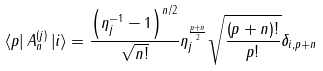Convert formula to latex. <formula><loc_0><loc_0><loc_500><loc_500>\left \langle p \right | A _ { n } ^ { ( j ) } \left | i \right \rangle = \frac { \left ( { \eta _ { j } ^ { - 1 } - 1 } \right ) ^ { n / 2 } } { \sqrt { n ! } } \eta _ { j } ^ { \frac { p + n } { 2 } } \sqrt { \frac { \left ( { p + n } \right ) ! } { p ! } } \delta _ { i , p + n }</formula> 